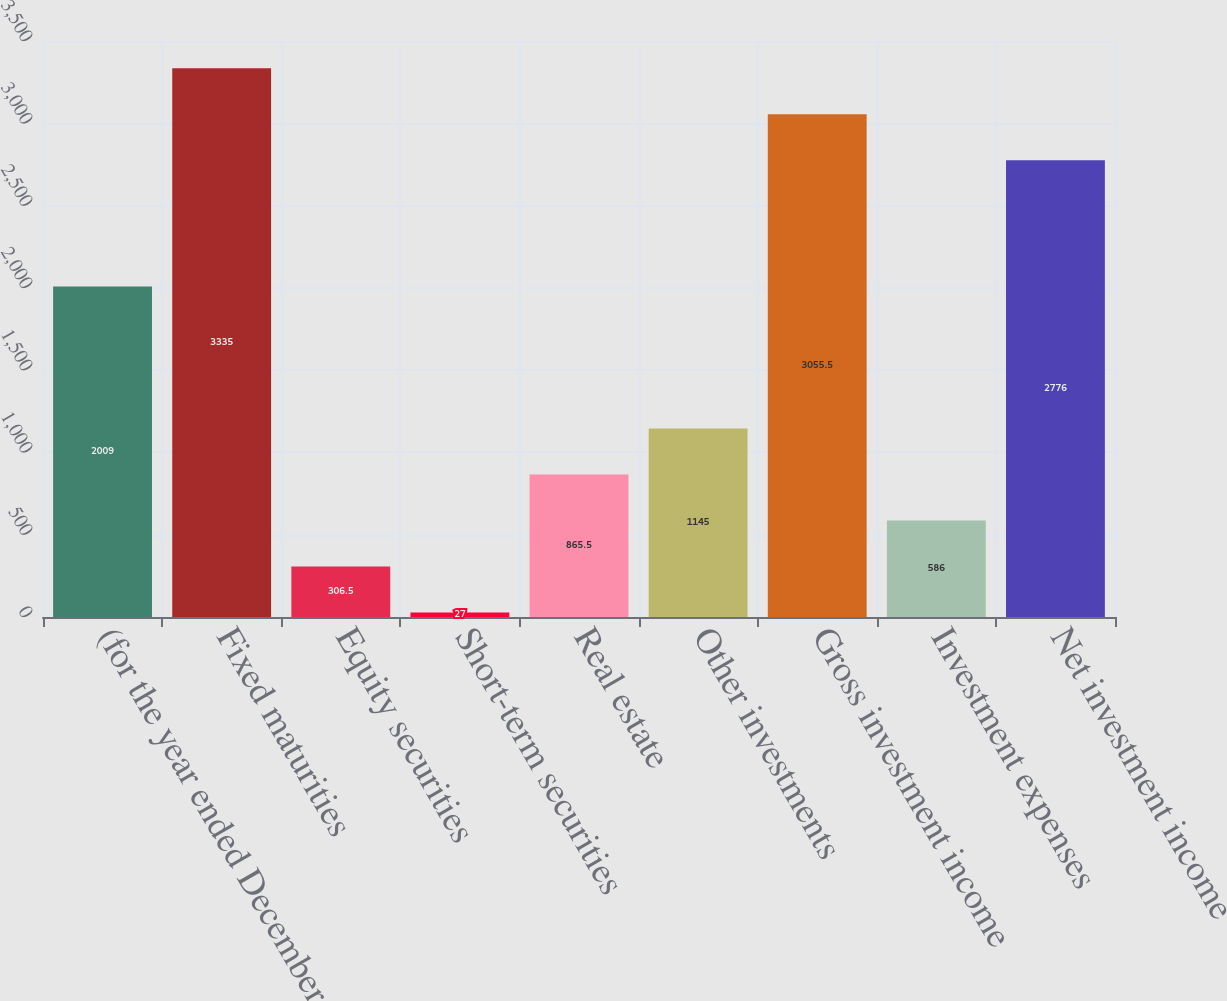Convert chart to OTSL. <chart><loc_0><loc_0><loc_500><loc_500><bar_chart><fcel>(for the year ended December<fcel>Fixed maturities<fcel>Equity securities<fcel>Short-term securities<fcel>Real estate<fcel>Other investments<fcel>Gross investment income<fcel>Investment expenses<fcel>Net investment income<nl><fcel>2009<fcel>3335<fcel>306.5<fcel>27<fcel>865.5<fcel>1145<fcel>3055.5<fcel>586<fcel>2776<nl></chart> 